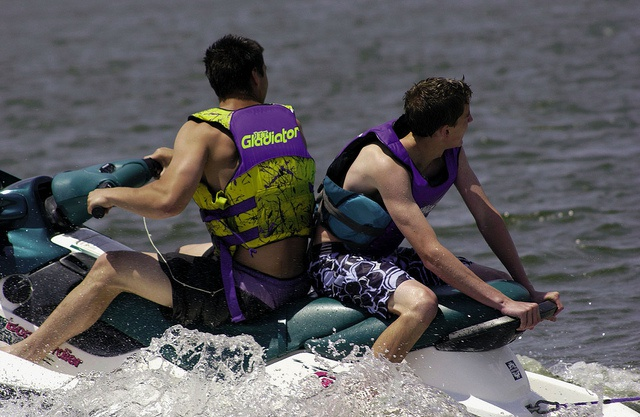Describe the objects in this image and their specific colors. I can see boat in gray, black, darkgray, and lightgray tones, people in gray, black, and olive tones, and people in gray, black, and maroon tones in this image. 